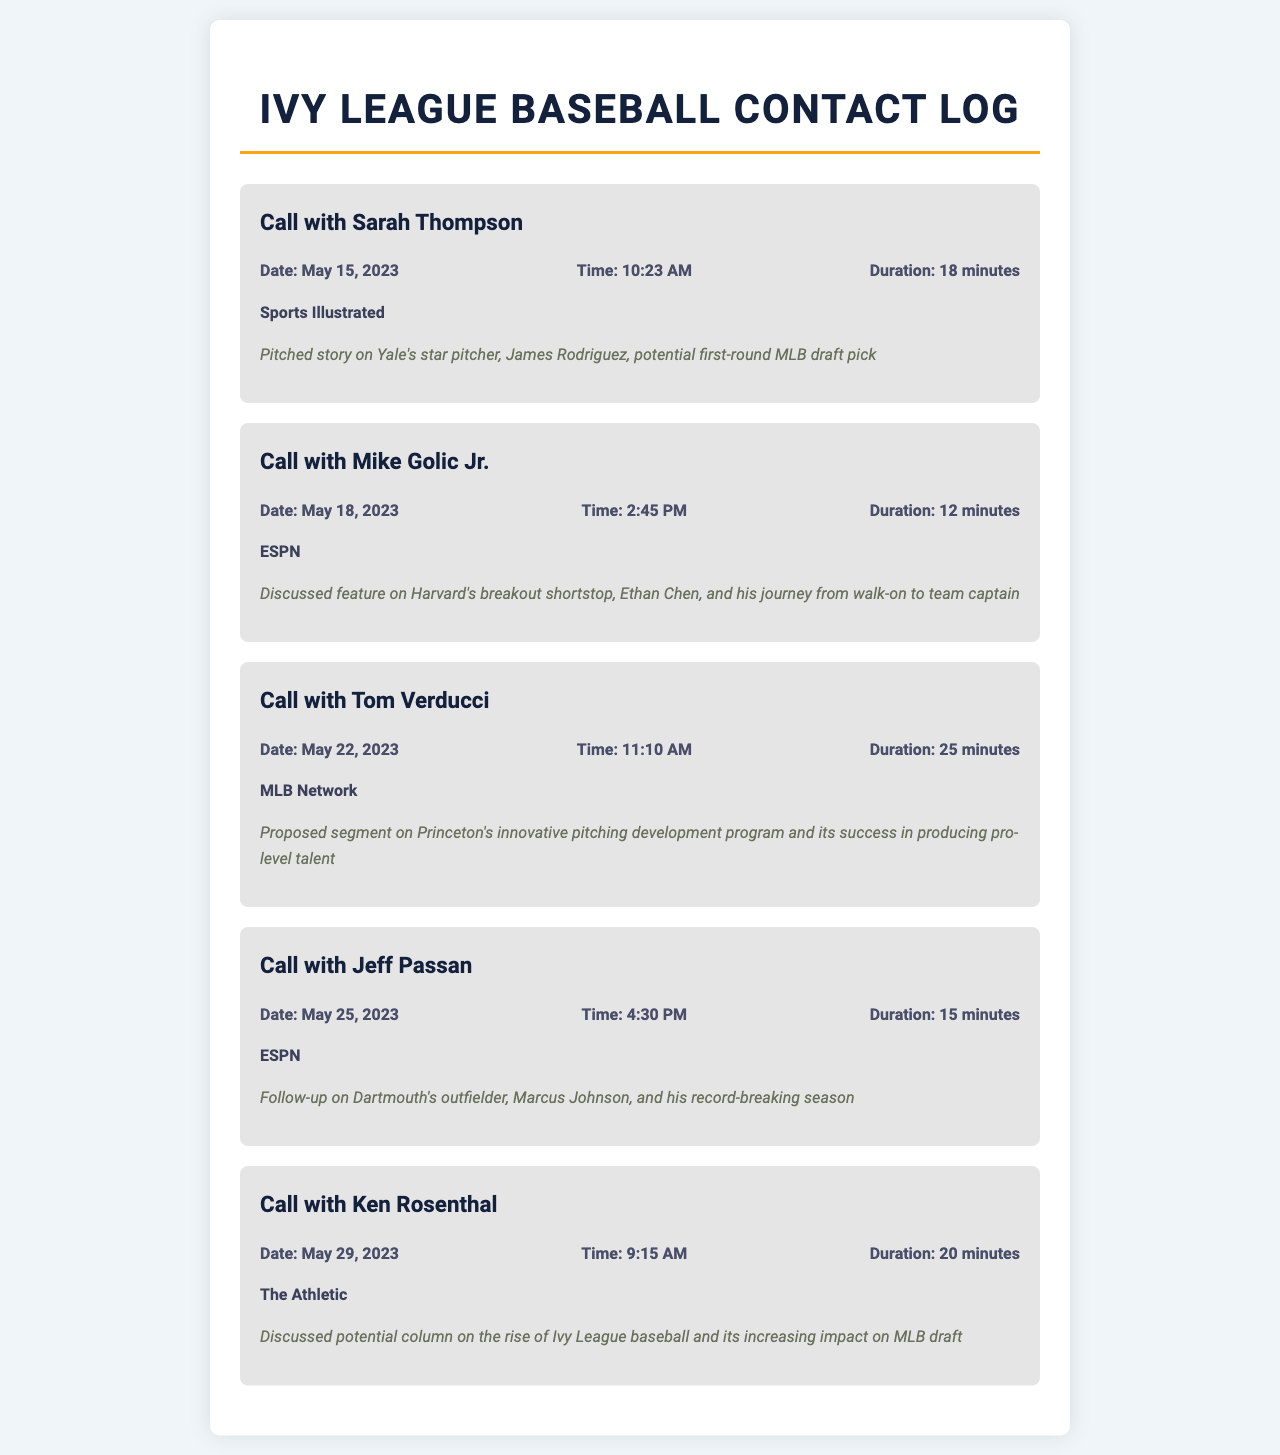What is the name of the editor with whom you discussed James Rodriguez? The name is mentioned in the call record for the discussion on Yale's star pitcher.
Answer: Sarah Thompson On what date did you call Mike Golic Jr.? The date can be found in the record of the call with Mike Golic Jr.
Answer: May 18, 2023 How long was the call with Tom Verducci? The duration of the call is indicated in the call record with Tom Verducci.
Answer: 25 minutes What publication is associated with the discussion on Ethan Chen? The publication that published the feature on Harvard's shortstop is identified in the relevant call record.
Answer: ESPN What was the main topic discussed with Jeff Passan? The main topic is outlined in the notes of the call with Jeff Passan concerning a specific player.
Answer: Dartmouth's outfielder, Marcus Johnson How many calls were made regarding Ivy League players' stories? The number is derived from all the call records focusing on Ivy League players' stories.
Answer: Five Which player was highlighted in the call with Ken Rosenthal? The player discussed in this call is noted in the call record, referencing the context of the conversation.
Answer: Ivy League baseball What was proposed in the call with Tom Verducci? The proposal discussed is specifically mentioned in the notes for the call with Tom Verducci.
Answer: Segment on Princeton's pitching development program What is the total number of publications mentioned in the document? Each call identifies a unique publication, contributing to the total count.
Answer: Five 